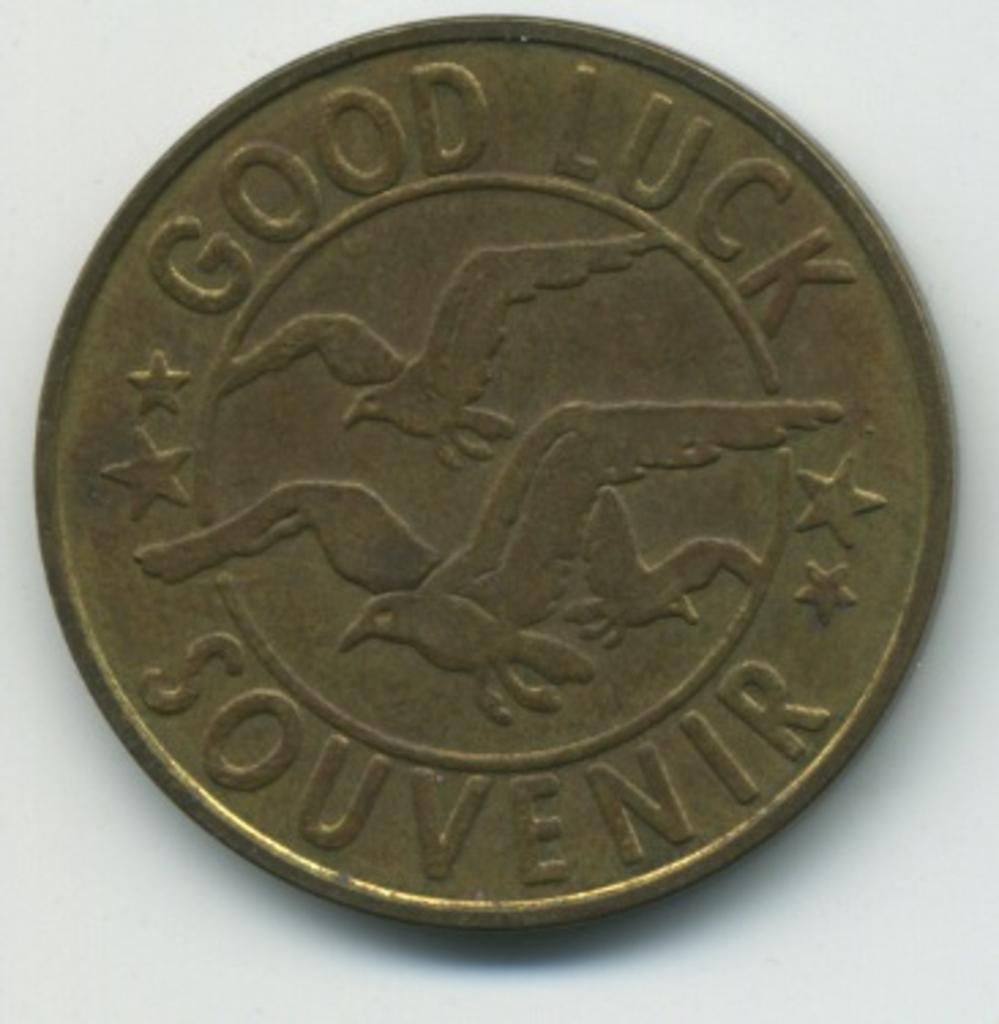<image>
Offer a succinct explanation of the picture presented. A bronze coin engraved with good luck souvenir depicts three eagles flying. 